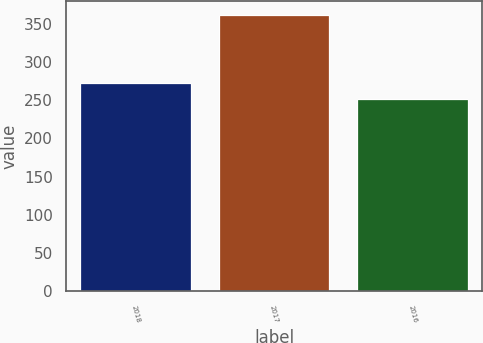Convert chart. <chart><loc_0><loc_0><loc_500><loc_500><bar_chart><fcel>2018<fcel>2017<fcel>2016<nl><fcel>272<fcel>361<fcel>251<nl></chart> 